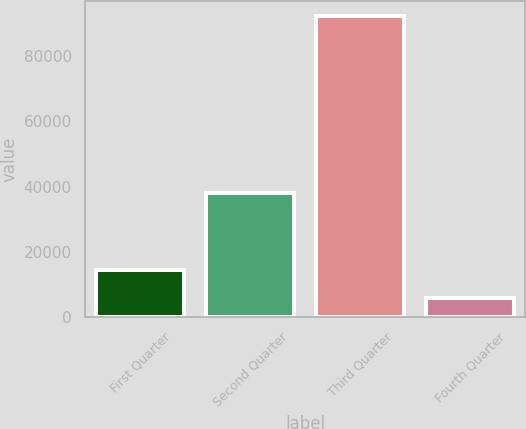Convert chart to OTSL. <chart><loc_0><loc_0><loc_500><loc_500><bar_chart><fcel>First Quarter<fcel>Second Quarter<fcel>Third Quarter<fcel>Fourth Quarter<nl><fcel>14632.6<fcel>38193<fcel>92281<fcel>6005<nl></chart> 